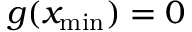<formula> <loc_0><loc_0><loc_500><loc_500>g ( x _ { \min } ) = 0</formula> 